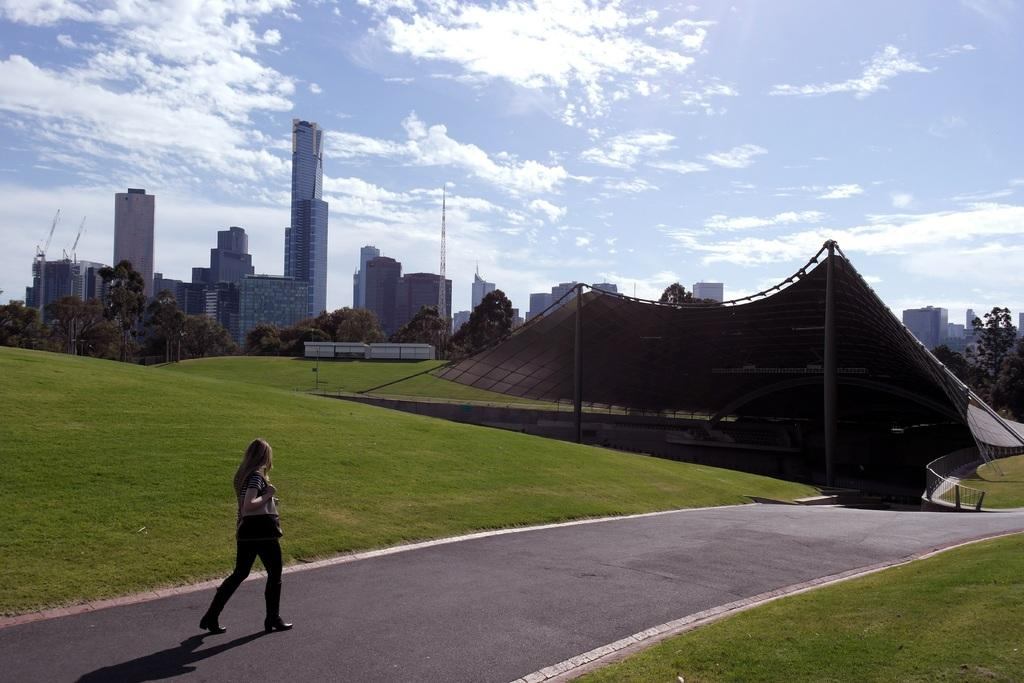What type of structures can be seen in the image? There are buildings, towers, and a monument in the image. What other natural elements are present in the image? There are trees in the image. Can you describe the lady in the image? The lady is wearing a bag and walking on the road. What is visible in the sky at the top of the image? There are clouds in the sky. What type of oatmeal is the lady eating while walking on the road? There is no oatmeal present in the image; the lady is not eating anything. What reward can be seen hanging from the monument in the image? There is no reward hanging from the monument in the image; the monument is not associated with any rewards. 